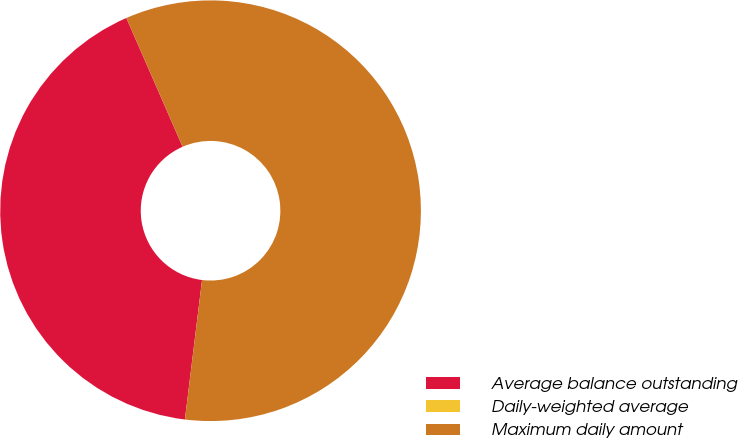<chart> <loc_0><loc_0><loc_500><loc_500><pie_chart><fcel>Average balance outstanding<fcel>Daily-weighted average<fcel>Maximum daily amount<nl><fcel>41.5%<fcel>0.0%<fcel>58.5%<nl></chart> 